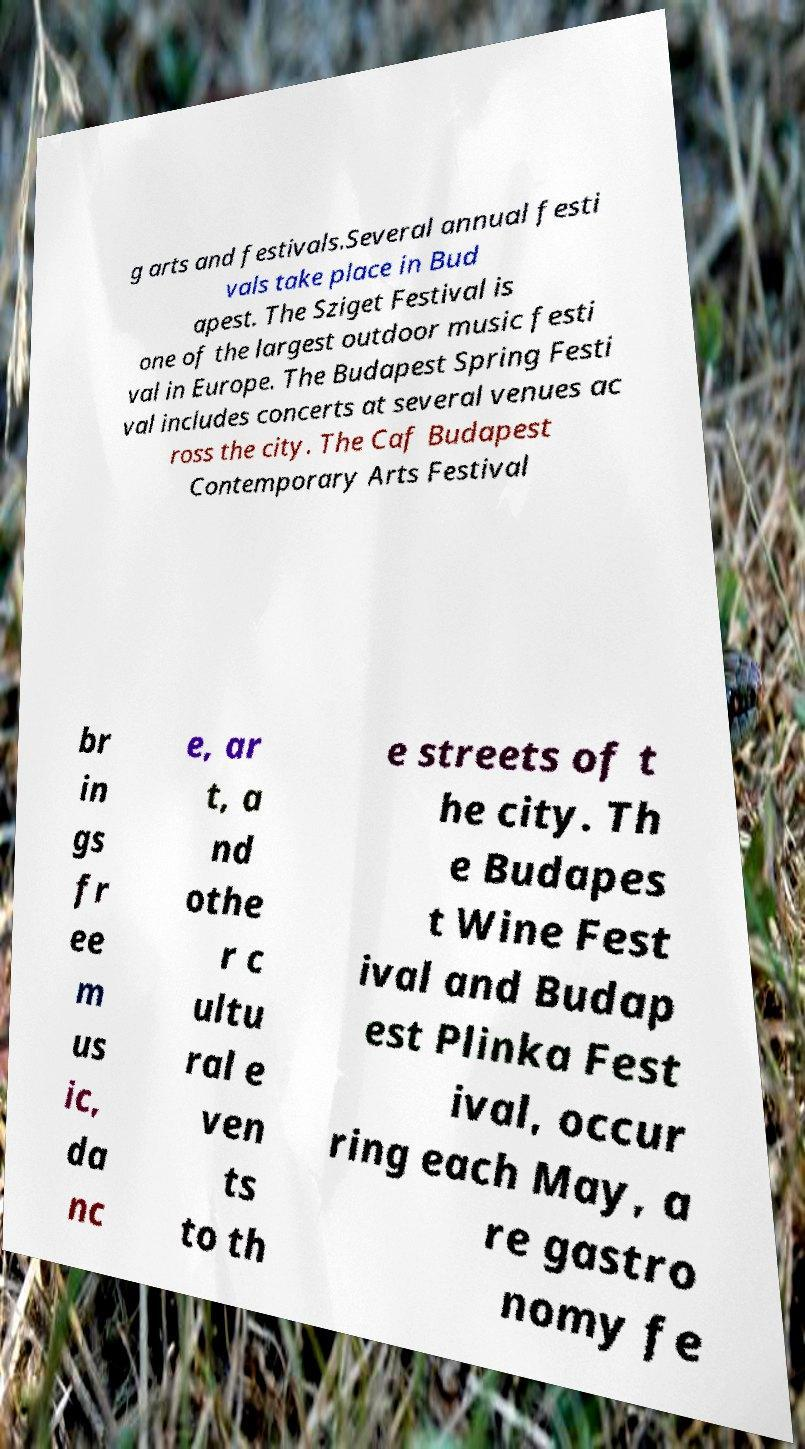For documentation purposes, I need the text within this image transcribed. Could you provide that? g arts and festivals.Several annual festi vals take place in Bud apest. The Sziget Festival is one of the largest outdoor music festi val in Europe. The Budapest Spring Festi val includes concerts at several venues ac ross the city. The Caf Budapest Contemporary Arts Festival br in gs fr ee m us ic, da nc e, ar t, a nd othe r c ultu ral e ven ts to th e streets of t he city. Th e Budapes t Wine Fest ival and Budap est Plinka Fest ival, occur ring each May, a re gastro nomy fe 